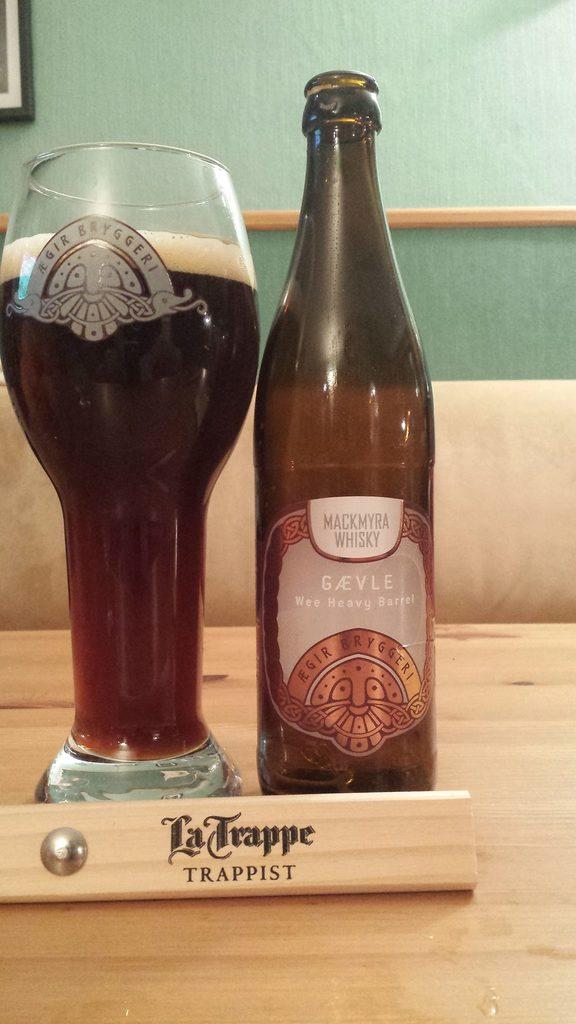<image>
Offer a succinct explanation of the picture presented. A bottle and glass sit behind a piece of wood that says La Trappe. 